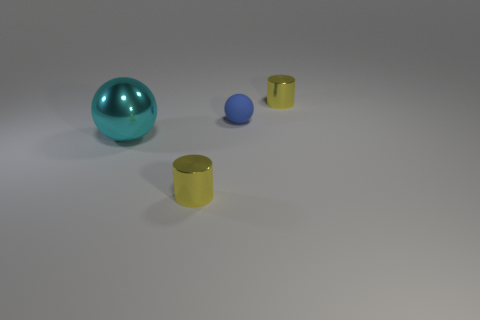Add 1 red rubber cylinders. How many objects exist? 5 Subtract all large cyan balls. Subtract all small blue spheres. How many objects are left? 2 Add 3 large cyan metallic balls. How many large cyan metallic balls are left? 4 Add 2 blue cylinders. How many blue cylinders exist? 2 Subtract 0 gray cylinders. How many objects are left? 4 